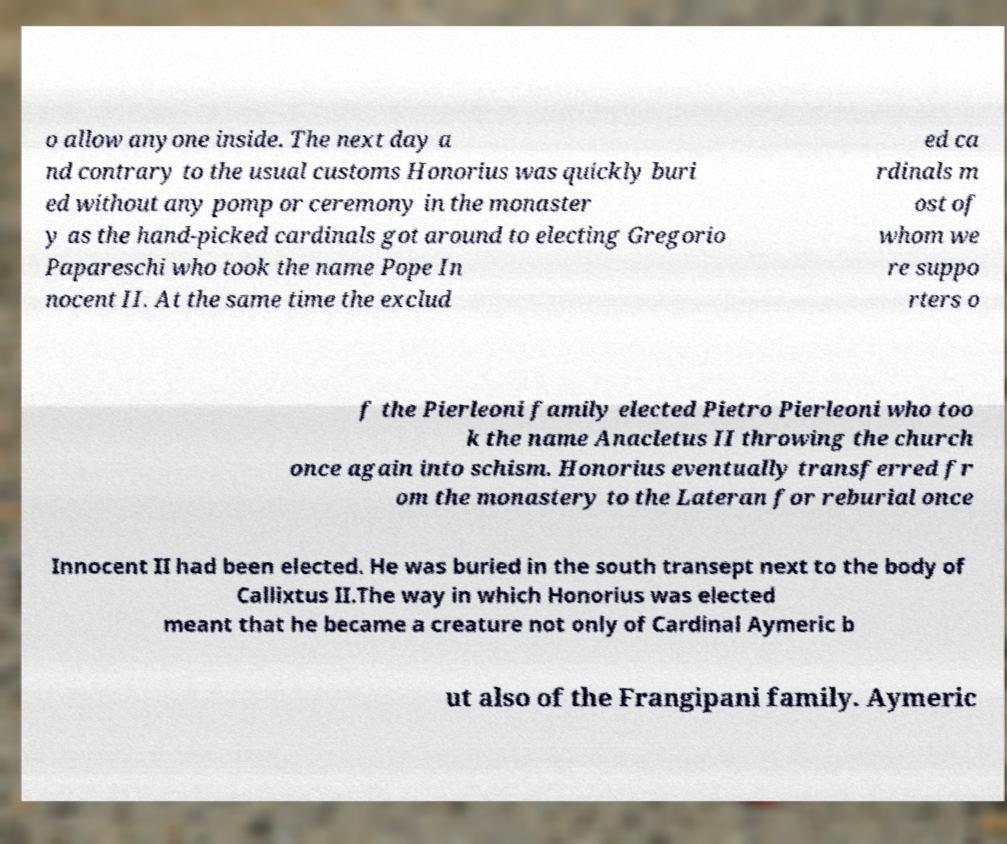I need the written content from this picture converted into text. Can you do that? o allow anyone inside. The next day a nd contrary to the usual customs Honorius was quickly buri ed without any pomp or ceremony in the monaster y as the hand-picked cardinals got around to electing Gregorio Papareschi who took the name Pope In nocent II. At the same time the exclud ed ca rdinals m ost of whom we re suppo rters o f the Pierleoni family elected Pietro Pierleoni who too k the name Anacletus II throwing the church once again into schism. Honorius eventually transferred fr om the monastery to the Lateran for reburial once Innocent II had been elected. He was buried in the south transept next to the body of Callixtus II.The way in which Honorius was elected meant that he became a creature not only of Cardinal Aymeric b ut also of the Frangipani family. Aymeric 